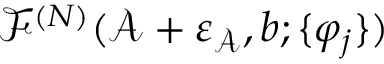Convert formula to latex. <formula><loc_0><loc_0><loc_500><loc_500>\mathcal { F } ^ { ( N ) } ( \mathcal { A } + \varepsilon _ { \mathcal { A } } , b ; \{ \varphi _ { j } \} )</formula> 